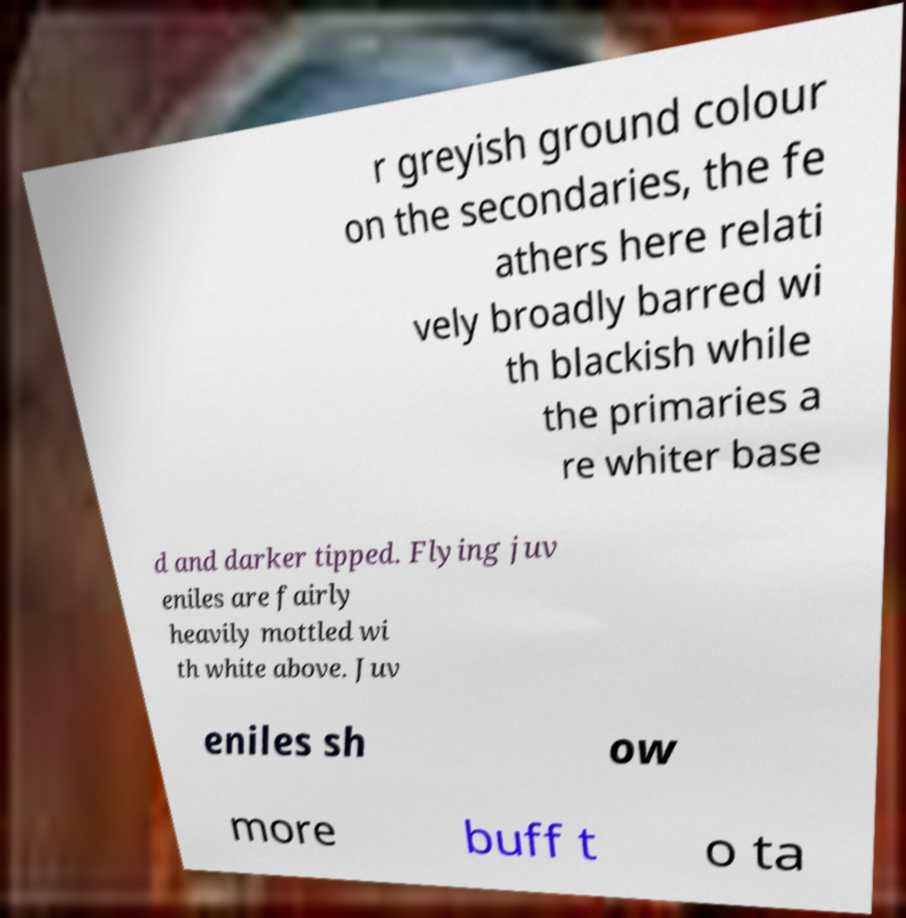Please read and relay the text visible in this image. What does it say? r greyish ground colour on the secondaries, the fe athers here relati vely broadly barred wi th blackish while the primaries a re whiter base d and darker tipped. Flying juv eniles are fairly heavily mottled wi th white above. Juv eniles sh ow more buff t o ta 